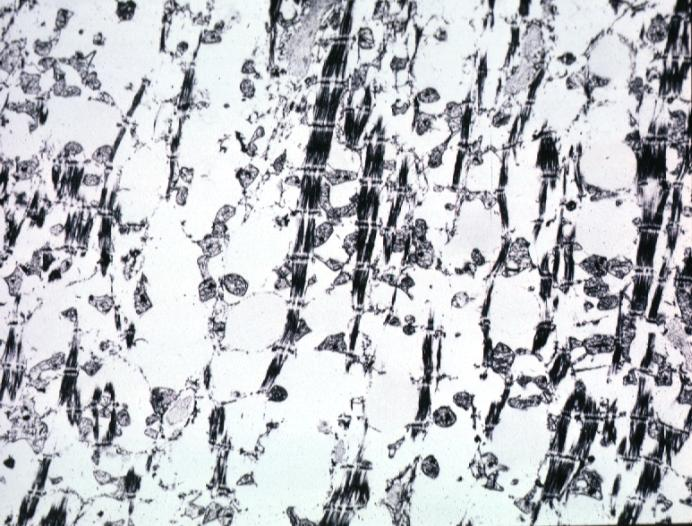what contains not lipid?
Answer the question using a single word or phrase. Lesion of myocytolysis 